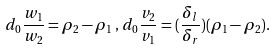<formula> <loc_0><loc_0><loc_500><loc_500>d _ { 0 } \frac { w _ { 1 } } { w _ { 2 } } = \rho _ { 2 } - \rho _ { 1 } \, , \, d _ { 0 } \frac { v _ { 2 } } { v _ { 1 } } = ( \frac { \delta _ { l } } { \delta _ { r } } ) ( \rho _ { 1 } - \rho _ { 2 } ) .</formula> 